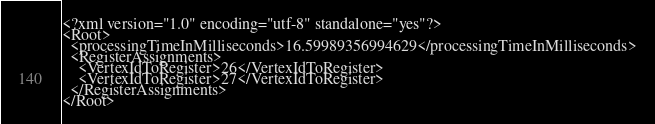Convert code to text. <code><loc_0><loc_0><loc_500><loc_500><_XML_><?xml version="1.0" encoding="utf-8" standalone="yes"?>
<Root>
  <processingTimeInMilliseconds>16.59989356994629</processingTimeInMilliseconds>
  <RegisterAssignments>
    <VertexIdToRegister>26</VertexIdToRegister>
    <VertexIdToRegister>27</VertexIdToRegister>
  </RegisterAssignments>
</Root>
</code> 